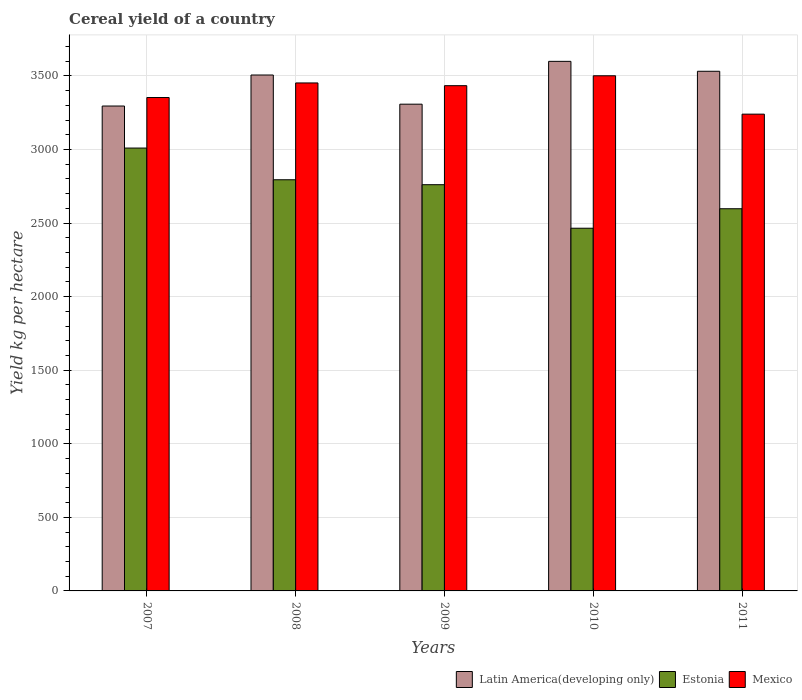How many different coloured bars are there?
Keep it short and to the point. 3. How many bars are there on the 5th tick from the right?
Offer a terse response. 3. In how many cases, is the number of bars for a given year not equal to the number of legend labels?
Ensure brevity in your answer.  0. What is the total cereal yield in Mexico in 2007?
Your answer should be compact. 3352.82. Across all years, what is the maximum total cereal yield in Latin America(developing only)?
Ensure brevity in your answer.  3598.65. Across all years, what is the minimum total cereal yield in Latin America(developing only)?
Provide a succinct answer. 3295.14. In which year was the total cereal yield in Latin America(developing only) maximum?
Your response must be concise. 2010. What is the total total cereal yield in Latin America(developing only) in the graph?
Your answer should be very brief. 1.72e+04. What is the difference between the total cereal yield in Latin America(developing only) in 2009 and that in 2011?
Your response must be concise. -223.57. What is the difference between the total cereal yield in Mexico in 2008 and the total cereal yield in Estonia in 2009?
Provide a short and direct response. 691.43. What is the average total cereal yield in Estonia per year?
Keep it short and to the point. 2725.16. In the year 2010, what is the difference between the total cereal yield in Mexico and total cereal yield in Latin America(developing only)?
Provide a short and direct response. -98.02. In how many years, is the total cereal yield in Latin America(developing only) greater than 3500 kg per hectare?
Your answer should be very brief. 3. What is the ratio of the total cereal yield in Estonia in 2008 to that in 2011?
Your answer should be very brief. 1.08. Is the total cereal yield in Estonia in 2008 less than that in 2009?
Your response must be concise. No. Is the difference between the total cereal yield in Mexico in 2008 and 2011 greater than the difference between the total cereal yield in Latin America(developing only) in 2008 and 2011?
Provide a succinct answer. Yes. What is the difference between the highest and the second highest total cereal yield in Mexico?
Your response must be concise. 48.68. What is the difference between the highest and the lowest total cereal yield in Estonia?
Make the answer very short. 544.75. In how many years, is the total cereal yield in Mexico greater than the average total cereal yield in Mexico taken over all years?
Ensure brevity in your answer.  3. Is the sum of the total cereal yield in Estonia in 2007 and 2011 greater than the maximum total cereal yield in Mexico across all years?
Offer a terse response. Yes. What does the 1st bar from the left in 2008 represents?
Provide a short and direct response. Latin America(developing only). What does the 3rd bar from the right in 2008 represents?
Make the answer very short. Latin America(developing only). Is it the case that in every year, the sum of the total cereal yield in Estonia and total cereal yield in Latin America(developing only) is greater than the total cereal yield in Mexico?
Give a very brief answer. Yes. Are all the bars in the graph horizontal?
Provide a short and direct response. No. How many years are there in the graph?
Ensure brevity in your answer.  5. What is the difference between two consecutive major ticks on the Y-axis?
Provide a succinct answer. 500. Are the values on the major ticks of Y-axis written in scientific E-notation?
Keep it short and to the point. No. Where does the legend appear in the graph?
Your response must be concise. Bottom right. How are the legend labels stacked?
Offer a terse response. Horizontal. What is the title of the graph?
Your answer should be very brief. Cereal yield of a country. Does "Aruba" appear as one of the legend labels in the graph?
Provide a succinct answer. No. What is the label or title of the Y-axis?
Your answer should be very brief. Yield kg per hectare. What is the Yield kg per hectare of Latin America(developing only) in 2007?
Your answer should be compact. 3295.14. What is the Yield kg per hectare of Estonia in 2007?
Provide a short and direct response. 3009.47. What is the Yield kg per hectare of Mexico in 2007?
Your answer should be very brief. 3352.82. What is the Yield kg per hectare in Latin America(developing only) in 2008?
Provide a succinct answer. 3505.87. What is the Yield kg per hectare in Estonia in 2008?
Offer a very short reply. 2794.05. What is the Yield kg per hectare of Mexico in 2008?
Provide a succinct answer. 3451.95. What is the Yield kg per hectare of Latin America(developing only) in 2009?
Ensure brevity in your answer.  3307.63. What is the Yield kg per hectare in Estonia in 2009?
Provide a short and direct response. 2760.53. What is the Yield kg per hectare of Mexico in 2009?
Your answer should be compact. 3433.35. What is the Yield kg per hectare of Latin America(developing only) in 2010?
Offer a terse response. 3598.65. What is the Yield kg per hectare of Estonia in 2010?
Your answer should be compact. 2464.72. What is the Yield kg per hectare in Mexico in 2010?
Ensure brevity in your answer.  3500.63. What is the Yield kg per hectare in Latin America(developing only) in 2011?
Ensure brevity in your answer.  3531.2. What is the Yield kg per hectare in Estonia in 2011?
Ensure brevity in your answer.  2597.05. What is the Yield kg per hectare in Mexico in 2011?
Offer a very short reply. 3239.93. Across all years, what is the maximum Yield kg per hectare of Latin America(developing only)?
Keep it short and to the point. 3598.65. Across all years, what is the maximum Yield kg per hectare in Estonia?
Offer a terse response. 3009.47. Across all years, what is the maximum Yield kg per hectare in Mexico?
Ensure brevity in your answer.  3500.63. Across all years, what is the minimum Yield kg per hectare of Latin America(developing only)?
Your response must be concise. 3295.14. Across all years, what is the minimum Yield kg per hectare of Estonia?
Provide a short and direct response. 2464.72. Across all years, what is the minimum Yield kg per hectare in Mexico?
Your response must be concise. 3239.93. What is the total Yield kg per hectare in Latin America(developing only) in the graph?
Provide a short and direct response. 1.72e+04. What is the total Yield kg per hectare in Estonia in the graph?
Your response must be concise. 1.36e+04. What is the total Yield kg per hectare of Mexico in the graph?
Your answer should be very brief. 1.70e+04. What is the difference between the Yield kg per hectare of Latin America(developing only) in 2007 and that in 2008?
Provide a short and direct response. -210.73. What is the difference between the Yield kg per hectare in Estonia in 2007 and that in 2008?
Keep it short and to the point. 215.42. What is the difference between the Yield kg per hectare in Mexico in 2007 and that in 2008?
Offer a very short reply. -99.13. What is the difference between the Yield kg per hectare in Latin America(developing only) in 2007 and that in 2009?
Ensure brevity in your answer.  -12.49. What is the difference between the Yield kg per hectare in Estonia in 2007 and that in 2009?
Ensure brevity in your answer.  248.94. What is the difference between the Yield kg per hectare of Mexico in 2007 and that in 2009?
Your answer should be compact. -80.53. What is the difference between the Yield kg per hectare of Latin America(developing only) in 2007 and that in 2010?
Provide a short and direct response. -303.51. What is the difference between the Yield kg per hectare in Estonia in 2007 and that in 2010?
Your answer should be very brief. 544.75. What is the difference between the Yield kg per hectare of Mexico in 2007 and that in 2010?
Offer a terse response. -147.81. What is the difference between the Yield kg per hectare in Latin America(developing only) in 2007 and that in 2011?
Your response must be concise. -236.06. What is the difference between the Yield kg per hectare in Estonia in 2007 and that in 2011?
Give a very brief answer. 412.42. What is the difference between the Yield kg per hectare in Mexico in 2007 and that in 2011?
Provide a short and direct response. 112.89. What is the difference between the Yield kg per hectare of Latin America(developing only) in 2008 and that in 2009?
Provide a short and direct response. 198.24. What is the difference between the Yield kg per hectare of Estonia in 2008 and that in 2009?
Keep it short and to the point. 33.53. What is the difference between the Yield kg per hectare of Mexico in 2008 and that in 2009?
Provide a succinct answer. 18.6. What is the difference between the Yield kg per hectare in Latin America(developing only) in 2008 and that in 2010?
Your answer should be compact. -92.78. What is the difference between the Yield kg per hectare in Estonia in 2008 and that in 2010?
Your answer should be compact. 329.34. What is the difference between the Yield kg per hectare in Mexico in 2008 and that in 2010?
Offer a terse response. -48.68. What is the difference between the Yield kg per hectare in Latin America(developing only) in 2008 and that in 2011?
Keep it short and to the point. -25.33. What is the difference between the Yield kg per hectare in Estonia in 2008 and that in 2011?
Your response must be concise. 197.01. What is the difference between the Yield kg per hectare of Mexico in 2008 and that in 2011?
Your answer should be very brief. 212.02. What is the difference between the Yield kg per hectare in Latin America(developing only) in 2009 and that in 2010?
Give a very brief answer. -291.02. What is the difference between the Yield kg per hectare in Estonia in 2009 and that in 2010?
Your answer should be very brief. 295.81. What is the difference between the Yield kg per hectare of Mexico in 2009 and that in 2010?
Your answer should be very brief. -67.28. What is the difference between the Yield kg per hectare in Latin America(developing only) in 2009 and that in 2011?
Offer a very short reply. -223.57. What is the difference between the Yield kg per hectare of Estonia in 2009 and that in 2011?
Offer a very short reply. 163.48. What is the difference between the Yield kg per hectare of Mexico in 2009 and that in 2011?
Your answer should be compact. 193.41. What is the difference between the Yield kg per hectare of Latin America(developing only) in 2010 and that in 2011?
Keep it short and to the point. 67.45. What is the difference between the Yield kg per hectare of Estonia in 2010 and that in 2011?
Offer a terse response. -132.33. What is the difference between the Yield kg per hectare of Mexico in 2010 and that in 2011?
Ensure brevity in your answer.  260.69. What is the difference between the Yield kg per hectare in Latin America(developing only) in 2007 and the Yield kg per hectare in Estonia in 2008?
Offer a terse response. 501.09. What is the difference between the Yield kg per hectare in Latin America(developing only) in 2007 and the Yield kg per hectare in Mexico in 2008?
Your answer should be compact. -156.81. What is the difference between the Yield kg per hectare of Estonia in 2007 and the Yield kg per hectare of Mexico in 2008?
Give a very brief answer. -442.48. What is the difference between the Yield kg per hectare of Latin America(developing only) in 2007 and the Yield kg per hectare of Estonia in 2009?
Keep it short and to the point. 534.61. What is the difference between the Yield kg per hectare in Latin America(developing only) in 2007 and the Yield kg per hectare in Mexico in 2009?
Make the answer very short. -138.21. What is the difference between the Yield kg per hectare in Estonia in 2007 and the Yield kg per hectare in Mexico in 2009?
Your answer should be very brief. -423.88. What is the difference between the Yield kg per hectare in Latin America(developing only) in 2007 and the Yield kg per hectare in Estonia in 2010?
Your response must be concise. 830.42. What is the difference between the Yield kg per hectare of Latin America(developing only) in 2007 and the Yield kg per hectare of Mexico in 2010?
Keep it short and to the point. -205.49. What is the difference between the Yield kg per hectare of Estonia in 2007 and the Yield kg per hectare of Mexico in 2010?
Your answer should be compact. -491.16. What is the difference between the Yield kg per hectare in Latin America(developing only) in 2007 and the Yield kg per hectare in Estonia in 2011?
Provide a succinct answer. 698.09. What is the difference between the Yield kg per hectare of Latin America(developing only) in 2007 and the Yield kg per hectare of Mexico in 2011?
Ensure brevity in your answer.  55.2. What is the difference between the Yield kg per hectare in Estonia in 2007 and the Yield kg per hectare in Mexico in 2011?
Provide a short and direct response. -230.47. What is the difference between the Yield kg per hectare in Latin America(developing only) in 2008 and the Yield kg per hectare in Estonia in 2009?
Ensure brevity in your answer.  745.34. What is the difference between the Yield kg per hectare in Latin America(developing only) in 2008 and the Yield kg per hectare in Mexico in 2009?
Your answer should be very brief. 72.52. What is the difference between the Yield kg per hectare of Estonia in 2008 and the Yield kg per hectare of Mexico in 2009?
Give a very brief answer. -639.3. What is the difference between the Yield kg per hectare in Latin America(developing only) in 2008 and the Yield kg per hectare in Estonia in 2010?
Keep it short and to the point. 1041.15. What is the difference between the Yield kg per hectare of Latin America(developing only) in 2008 and the Yield kg per hectare of Mexico in 2010?
Provide a short and direct response. 5.24. What is the difference between the Yield kg per hectare of Estonia in 2008 and the Yield kg per hectare of Mexico in 2010?
Your response must be concise. -706.58. What is the difference between the Yield kg per hectare of Latin America(developing only) in 2008 and the Yield kg per hectare of Estonia in 2011?
Provide a short and direct response. 908.82. What is the difference between the Yield kg per hectare in Latin America(developing only) in 2008 and the Yield kg per hectare in Mexico in 2011?
Offer a terse response. 265.93. What is the difference between the Yield kg per hectare of Estonia in 2008 and the Yield kg per hectare of Mexico in 2011?
Offer a very short reply. -445.88. What is the difference between the Yield kg per hectare in Latin America(developing only) in 2009 and the Yield kg per hectare in Estonia in 2010?
Offer a terse response. 842.92. What is the difference between the Yield kg per hectare of Latin America(developing only) in 2009 and the Yield kg per hectare of Mexico in 2010?
Your answer should be compact. -193. What is the difference between the Yield kg per hectare of Estonia in 2009 and the Yield kg per hectare of Mexico in 2010?
Your response must be concise. -740.11. What is the difference between the Yield kg per hectare of Latin America(developing only) in 2009 and the Yield kg per hectare of Estonia in 2011?
Your response must be concise. 710.59. What is the difference between the Yield kg per hectare in Latin America(developing only) in 2009 and the Yield kg per hectare in Mexico in 2011?
Provide a succinct answer. 67.7. What is the difference between the Yield kg per hectare of Estonia in 2009 and the Yield kg per hectare of Mexico in 2011?
Your response must be concise. -479.41. What is the difference between the Yield kg per hectare of Latin America(developing only) in 2010 and the Yield kg per hectare of Estonia in 2011?
Offer a very short reply. 1001.61. What is the difference between the Yield kg per hectare of Latin America(developing only) in 2010 and the Yield kg per hectare of Mexico in 2011?
Make the answer very short. 358.72. What is the difference between the Yield kg per hectare of Estonia in 2010 and the Yield kg per hectare of Mexico in 2011?
Ensure brevity in your answer.  -775.22. What is the average Yield kg per hectare in Latin America(developing only) per year?
Provide a short and direct response. 3447.7. What is the average Yield kg per hectare in Estonia per year?
Make the answer very short. 2725.16. What is the average Yield kg per hectare of Mexico per year?
Keep it short and to the point. 3395.74. In the year 2007, what is the difference between the Yield kg per hectare in Latin America(developing only) and Yield kg per hectare in Estonia?
Ensure brevity in your answer.  285.67. In the year 2007, what is the difference between the Yield kg per hectare in Latin America(developing only) and Yield kg per hectare in Mexico?
Provide a short and direct response. -57.68. In the year 2007, what is the difference between the Yield kg per hectare in Estonia and Yield kg per hectare in Mexico?
Your answer should be very brief. -343.36. In the year 2008, what is the difference between the Yield kg per hectare of Latin America(developing only) and Yield kg per hectare of Estonia?
Your response must be concise. 711.82. In the year 2008, what is the difference between the Yield kg per hectare of Latin America(developing only) and Yield kg per hectare of Mexico?
Provide a short and direct response. 53.92. In the year 2008, what is the difference between the Yield kg per hectare of Estonia and Yield kg per hectare of Mexico?
Your answer should be compact. -657.9. In the year 2009, what is the difference between the Yield kg per hectare of Latin America(developing only) and Yield kg per hectare of Estonia?
Give a very brief answer. 547.11. In the year 2009, what is the difference between the Yield kg per hectare of Latin America(developing only) and Yield kg per hectare of Mexico?
Offer a terse response. -125.72. In the year 2009, what is the difference between the Yield kg per hectare in Estonia and Yield kg per hectare in Mexico?
Give a very brief answer. -672.82. In the year 2010, what is the difference between the Yield kg per hectare of Latin America(developing only) and Yield kg per hectare of Estonia?
Provide a short and direct response. 1133.94. In the year 2010, what is the difference between the Yield kg per hectare in Latin America(developing only) and Yield kg per hectare in Mexico?
Make the answer very short. 98.02. In the year 2010, what is the difference between the Yield kg per hectare in Estonia and Yield kg per hectare in Mexico?
Make the answer very short. -1035.91. In the year 2011, what is the difference between the Yield kg per hectare in Latin America(developing only) and Yield kg per hectare in Estonia?
Your answer should be compact. 934.16. In the year 2011, what is the difference between the Yield kg per hectare of Latin America(developing only) and Yield kg per hectare of Mexico?
Provide a short and direct response. 291.27. In the year 2011, what is the difference between the Yield kg per hectare of Estonia and Yield kg per hectare of Mexico?
Give a very brief answer. -642.89. What is the ratio of the Yield kg per hectare of Latin America(developing only) in 2007 to that in 2008?
Give a very brief answer. 0.94. What is the ratio of the Yield kg per hectare in Estonia in 2007 to that in 2008?
Provide a short and direct response. 1.08. What is the ratio of the Yield kg per hectare of Mexico in 2007 to that in 2008?
Ensure brevity in your answer.  0.97. What is the ratio of the Yield kg per hectare of Estonia in 2007 to that in 2009?
Offer a terse response. 1.09. What is the ratio of the Yield kg per hectare of Mexico in 2007 to that in 2009?
Ensure brevity in your answer.  0.98. What is the ratio of the Yield kg per hectare in Latin America(developing only) in 2007 to that in 2010?
Make the answer very short. 0.92. What is the ratio of the Yield kg per hectare of Estonia in 2007 to that in 2010?
Keep it short and to the point. 1.22. What is the ratio of the Yield kg per hectare of Mexico in 2007 to that in 2010?
Your response must be concise. 0.96. What is the ratio of the Yield kg per hectare of Latin America(developing only) in 2007 to that in 2011?
Offer a terse response. 0.93. What is the ratio of the Yield kg per hectare of Estonia in 2007 to that in 2011?
Ensure brevity in your answer.  1.16. What is the ratio of the Yield kg per hectare of Mexico in 2007 to that in 2011?
Your response must be concise. 1.03. What is the ratio of the Yield kg per hectare in Latin America(developing only) in 2008 to that in 2009?
Offer a terse response. 1.06. What is the ratio of the Yield kg per hectare in Estonia in 2008 to that in 2009?
Offer a terse response. 1.01. What is the ratio of the Yield kg per hectare of Mexico in 2008 to that in 2009?
Ensure brevity in your answer.  1.01. What is the ratio of the Yield kg per hectare in Latin America(developing only) in 2008 to that in 2010?
Provide a succinct answer. 0.97. What is the ratio of the Yield kg per hectare of Estonia in 2008 to that in 2010?
Your response must be concise. 1.13. What is the ratio of the Yield kg per hectare in Mexico in 2008 to that in 2010?
Offer a terse response. 0.99. What is the ratio of the Yield kg per hectare of Estonia in 2008 to that in 2011?
Provide a succinct answer. 1.08. What is the ratio of the Yield kg per hectare of Mexico in 2008 to that in 2011?
Offer a terse response. 1.07. What is the ratio of the Yield kg per hectare in Latin America(developing only) in 2009 to that in 2010?
Your answer should be compact. 0.92. What is the ratio of the Yield kg per hectare in Estonia in 2009 to that in 2010?
Provide a short and direct response. 1.12. What is the ratio of the Yield kg per hectare of Mexico in 2009 to that in 2010?
Make the answer very short. 0.98. What is the ratio of the Yield kg per hectare in Latin America(developing only) in 2009 to that in 2011?
Offer a very short reply. 0.94. What is the ratio of the Yield kg per hectare in Estonia in 2009 to that in 2011?
Ensure brevity in your answer.  1.06. What is the ratio of the Yield kg per hectare of Mexico in 2009 to that in 2011?
Provide a short and direct response. 1.06. What is the ratio of the Yield kg per hectare of Latin America(developing only) in 2010 to that in 2011?
Offer a terse response. 1.02. What is the ratio of the Yield kg per hectare of Estonia in 2010 to that in 2011?
Offer a very short reply. 0.95. What is the ratio of the Yield kg per hectare in Mexico in 2010 to that in 2011?
Give a very brief answer. 1.08. What is the difference between the highest and the second highest Yield kg per hectare in Latin America(developing only)?
Provide a succinct answer. 67.45. What is the difference between the highest and the second highest Yield kg per hectare in Estonia?
Offer a very short reply. 215.42. What is the difference between the highest and the second highest Yield kg per hectare in Mexico?
Offer a terse response. 48.68. What is the difference between the highest and the lowest Yield kg per hectare of Latin America(developing only)?
Your answer should be compact. 303.51. What is the difference between the highest and the lowest Yield kg per hectare in Estonia?
Provide a short and direct response. 544.75. What is the difference between the highest and the lowest Yield kg per hectare of Mexico?
Your answer should be compact. 260.69. 